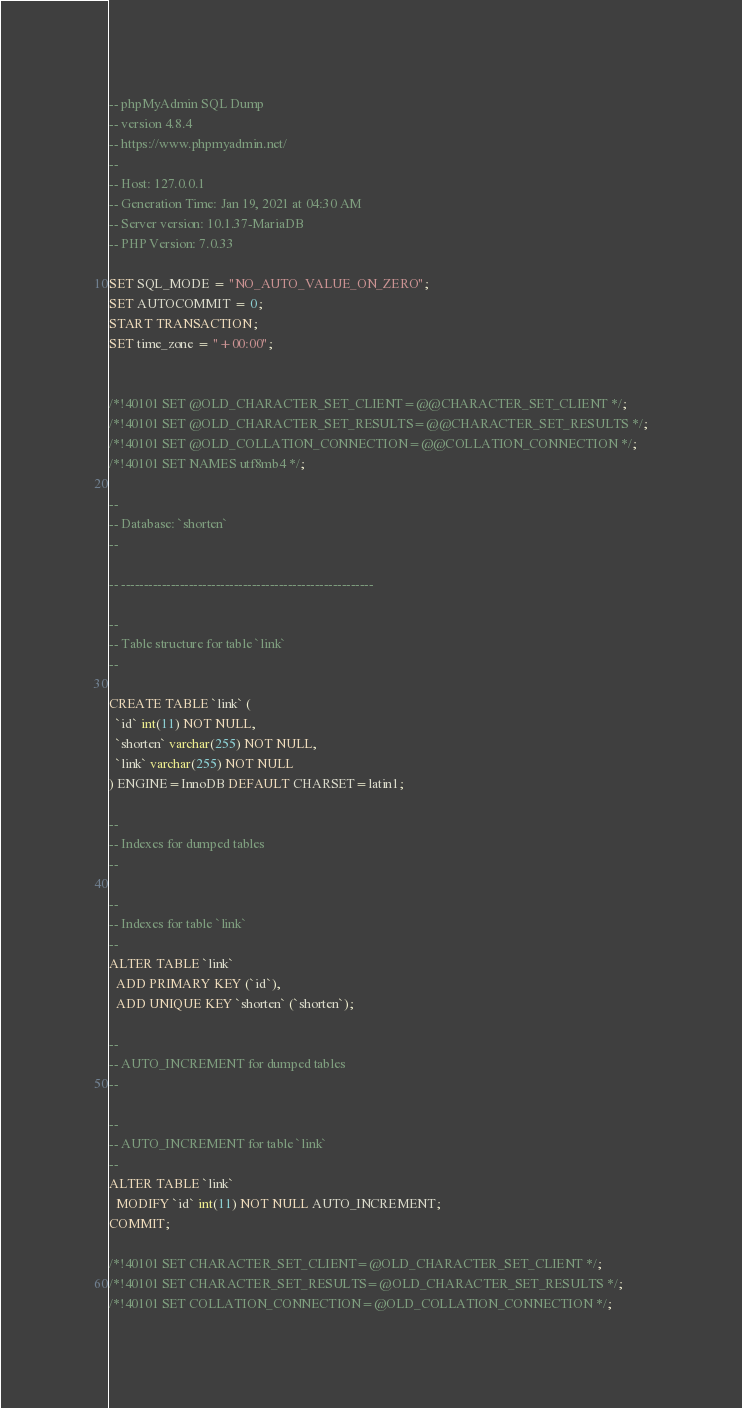Convert code to text. <code><loc_0><loc_0><loc_500><loc_500><_SQL_>-- phpMyAdmin SQL Dump
-- version 4.8.4
-- https://www.phpmyadmin.net/
--
-- Host: 127.0.0.1
-- Generation Time: Jan 19, 2021 at 04:30 AM
-- Server version: 10.1.37-MariaDB
-- PHP Version: 7.0.33

SET SQL_MODE = "NO_AUTO_VALUE_ON_ZERO";
SET AUTOCOMMIT = 0;
START TRANSACTION;
SET time_zone = "+00:00";


/*!40101 SET @OLD_CHARACTER_SET_CLIENT=@@CHARACTER_SET_CLIENT */;
/*!40101 SET @OLD_CHARACTER_SET_RESULTS=@@CHARACTER_SET_RESULTS */;
/*!40101 SET @OLD_COLLATION_CONNECTION=@@COLLATION_CONNECTION */;
/*!40101 SET NAMES utf8mb4 */;

--
-- Database: `shorten`
--

-- --------------------------------------------------------

--
-- Table structure for table `link`
--

CREATE TABLE `link` (
  `id` int(11) NOT NULL,
  `shorten` varchar(255) NOT NULL,
  `link` varchar(255) NOT NULL
) ENGINE=InnoDB DEFAULT CHARSET=latin1;

--
-- Indexes for dumped tables
--

--
-- Indexes for table `link`
--
ALTER TABLE `link`
  ADD PRIMARY KEY (`id`),
  ADD UNIQUE KEY `shorten` (`shorten`);

--
-- AUTO_INCREMENT for dumped tables
--

--
-- AUTO_INCREMENT for table `link`
--
ALTER TABLE `link`
  MODIFY `id` int(11) NOT NULL AUTO_INCREMENT;
COMMIT;

/*!40101 SET CHARACTER_SET_CLIENT=@OLD_CHARACTER_SET_CLIENT */;
/*!40101 SET CHARACTER_SET_RESULTS=@OLD_CHARACTER_SET_RESULTS */;
/*!40101 SET COLLATION_CONNECTION=@OLD_COLLATION_CONNECTION */;
</code> 